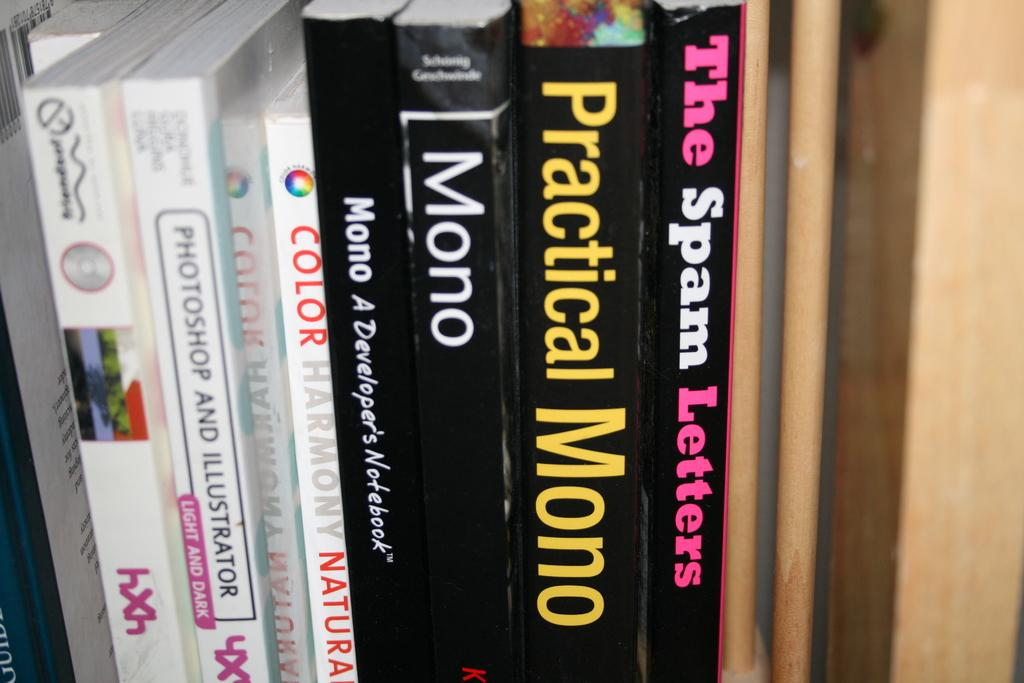<image>
Present a compact description of the photo's key features. Various books on a bookshelf about programming mono and Photoshop. 